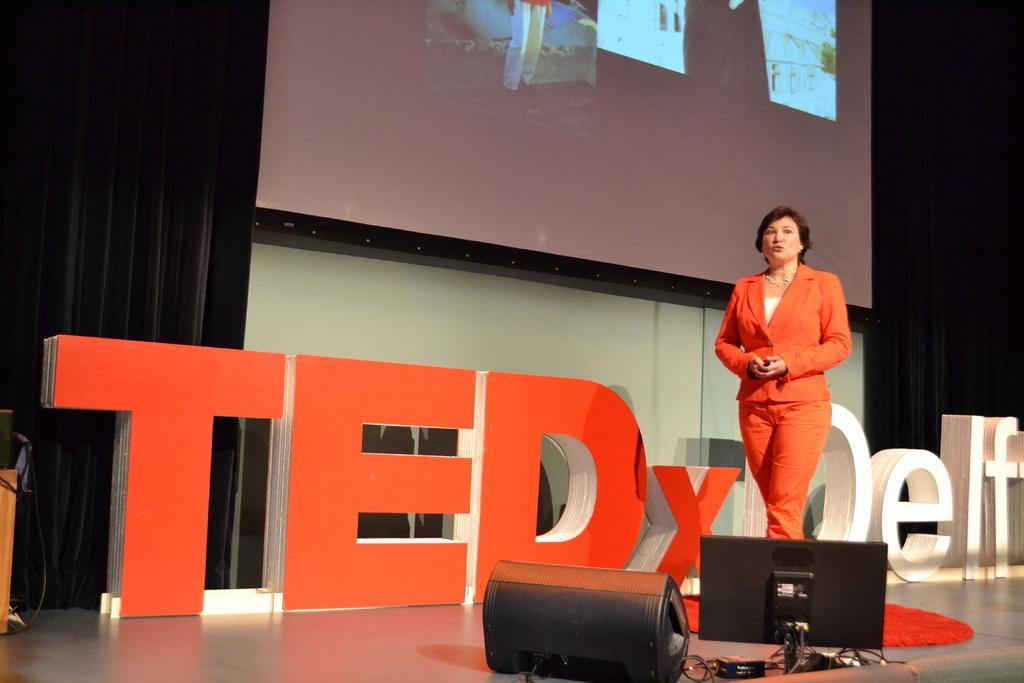In one or two sentences, can you explain what this image depicts? In this picture I can see there is a woman, she is walking and there is a screen and there is a black curtain here in the backdrop. 